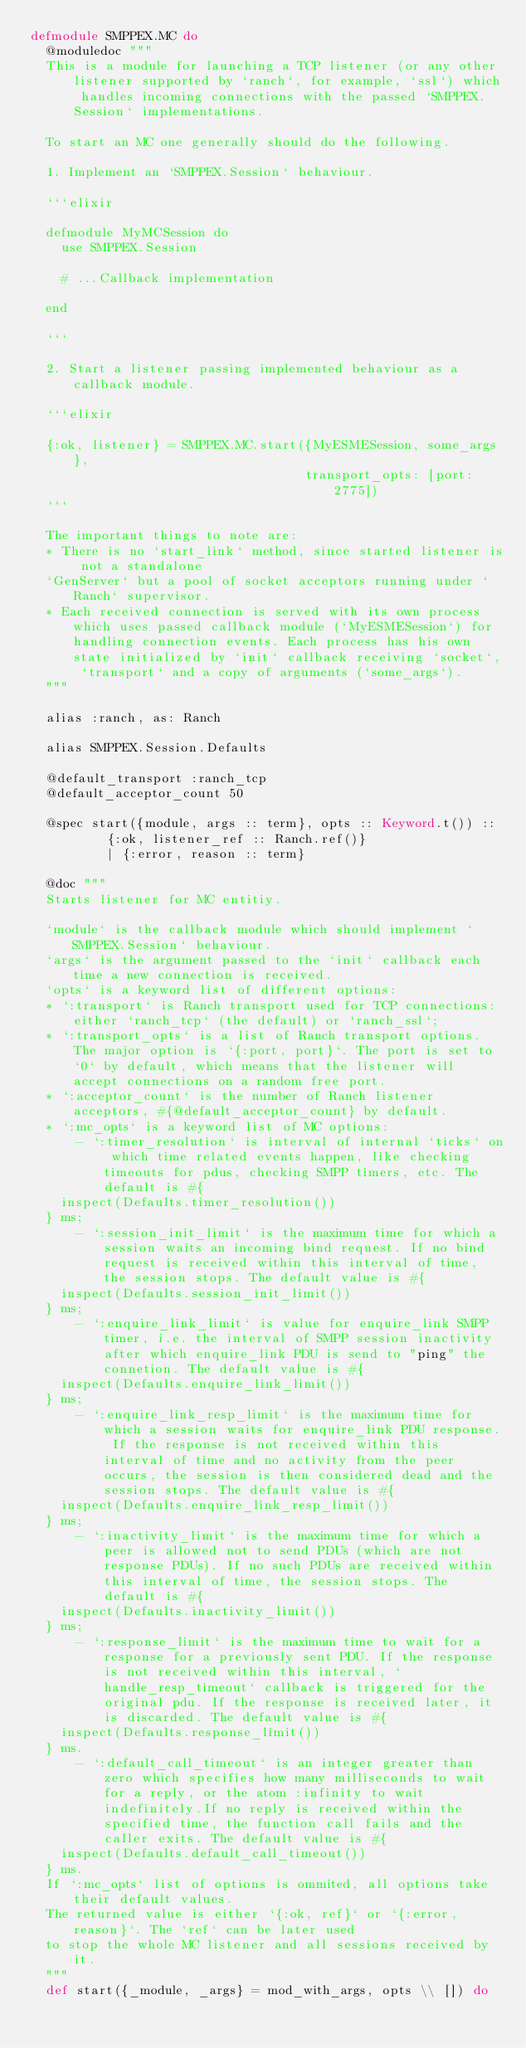<code> <loc_0><loc_0><loc_500><loc_500><_Elixir_>defmodule SMPPEX.MC do
  @moduledoc """
  This is a module for launching a TCP listener (or any other listener supported by `ranch`, for example, `ssl`) which handles incoming connections with the passed `SMPPEX.Session` implementations.

  To start an MC one generally should do the following.

  1. Implement an `SMPPEX.Session` behaviour.

  ```elixir

  defmodule MyMCSession do
    use SMPPEX.Session

    # ...Callback implementation

  end

  ```

  2. Start a listener passing implemented behaviour as a callback module.

  ```elixir

  {:ok, listener} = SMPPEX.MC.start({MyESMESession, some_args},
                                    transport_opts: [port: 2775])
  ```

  The important things to note are:
  * There is no `start_link` method, since started listener is not a standalone
  `GenServer` but a pool of socket acceptors running under `Ranch` supervisor.
  * Each received connection is served with its own process which uses passed callback module (`MyESMESession`) for handling connection events. Each process has his own state initialized by `init` callback receiving `socket`, `transport` and a copy of arguments (`some_args`).
  """

  alias :ranch, as: Ranch

  alias SMPPEX.Session.Defaults

  @default_transport :ranch_tcp
  @default_acceptor_count 50

  @spec start({module, args :: term}, opts :: Keyword.t()) ::
          {:ok, listener_ref :: Ranch.ref()}
          | {:error, reason :: term}

  @doc """
  Starts listener for MC entitiy.

  `module` is the callback module which should implement `SMPPEX.Session` behaviour.
  `args` is the argument passed to the `init` callback each time a new connection is received.
  `opts` is a keyword list of different options:
  * `:transport` is Ranch transport used for TCP connections: either `ranch_tcp` (the default) or `ranch_ssl`;
  * `:transport_opts` is a list of Ranch transport options. The major option is `{:port, port}`. The port is set to `0` by default, which means that the listener will accept connections on a random free port.
  * `:acceptor_count` is the number of Ranch listener acceptors, #{@default_acceptor_count} by default.
  * `:mc_opts` is a keyword list of MC options:
      - `:timer_resolution` is interval of internal `ticks` on which time related events happen, like checking timeouts for pdus, checking SMPP timers, etc. The default is #{
    inspect(Defaults.timer_resolution())
  } ms;
      - `:session_init_limit` is the maximum time for which a session waits an incoming bind request. If no bind request is received within this interval of time, the session stops. The default value is #{
    inspect(Defaults.session_init_limit())
  } ms;
      - `:enquire_link_limit` is value for enquire_link SMPP timer, i.e. the interval of SMPP session inactivity after which enquire_link PDU is send to "ping" the connetion. The default value is #{
    inspect(Defaults.enquire_link_limit())
  } ms;
      - `:enquire_link_resp_limit` is the maximum time for which a session waits for enquire_link PDU response. If the response is not received within this interval of time and no activity from the peer occurs, the session is then considered dead and the session stops. The default value is #{
    inspect(Defaults.enquire_link_resp_limit())
  } ms;
      - `:inactivity_limit` is the maximum time for which a peer is allowed not to send PDUs (which are not response PDUs). If no such PDUs are received within this interval of time, the session stops. The default is #{
    inspect(Defaults.inactivity_limit())
  } ms;
      - `:response_limit` is the maximum time to wait for a response for a previously sent PDU. If the response is not received within this interval, `handle_resp_timeout` callback is triggered for the original pdu. If the response is received later, it is discarded. The default value is #{
    inspect(Defaults.response_limit())
  } ms.
      - `:default_call_timeout` is an integer greater than zero which specifies how many milliseconds to wait for a reply, or the atom :infinity to wait indefinitely.If no reply is received within the specified time, the function call fails and the caller exits. The default value is #{
    inspect(Defaults.default_call_timeout())
  } ms.
  If `:mc_opts` list of options is ommited, all options take their default values.
  The returned value is either `{:ok, ref}` or `{:error, reason}`. The `ref` can be later used
  to stop the whole MC listener and all sessions received by it.
  """
  def start({_module, _args} = mod_with_args, opts \\ []) do</code> 